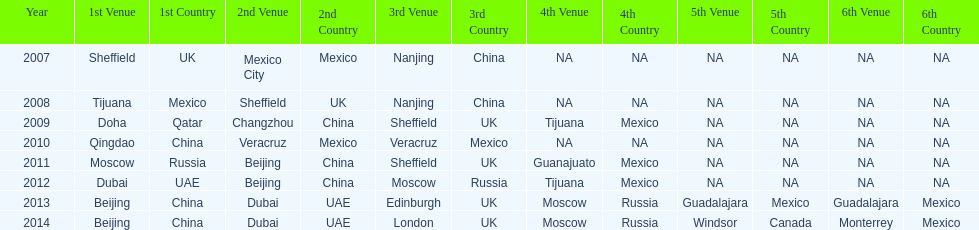Can you identify two venues that had no nations present from 2007 to 2012? 5th Venue, 6th Venue. 